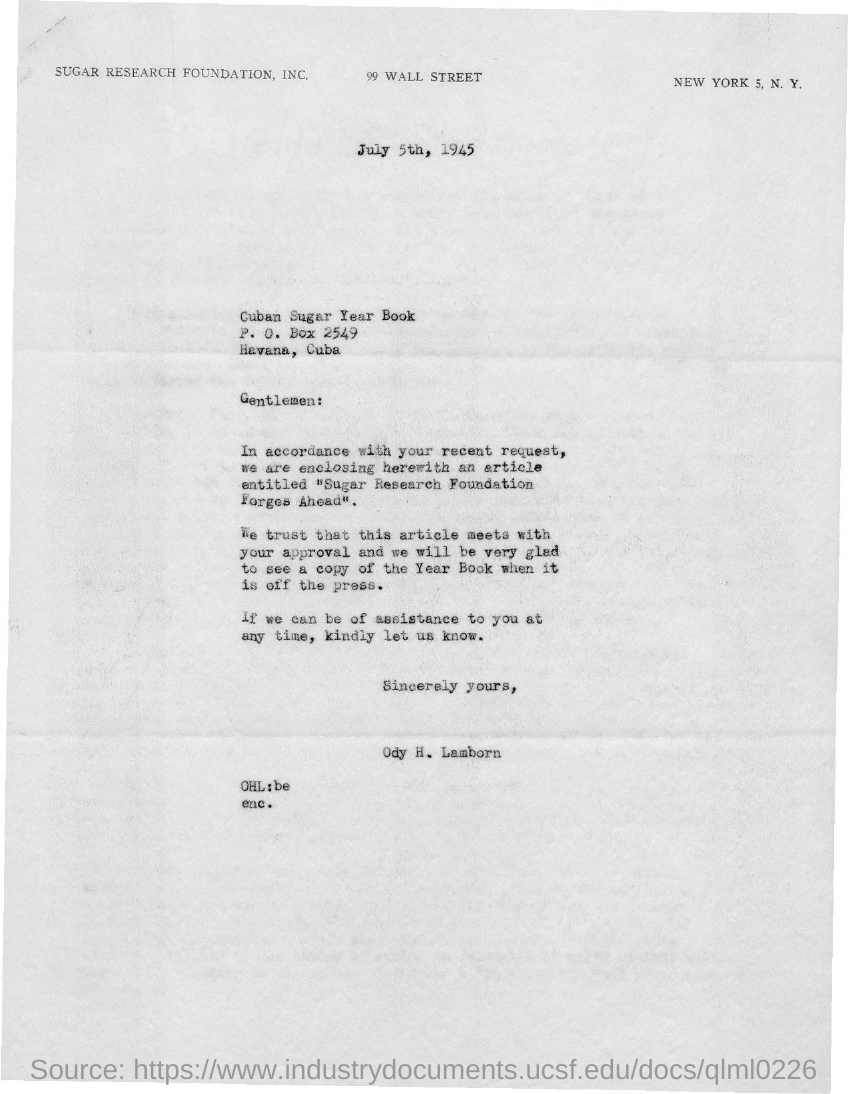What is the P.O.Box no given in the letter?
Your answer should be very brief. 2549. What is this letter dated?
Provide a succinct answer. July 5th, 1945. Who is the sender of this letter?
Give a very brief answer. ODY H. LAMBORN. 